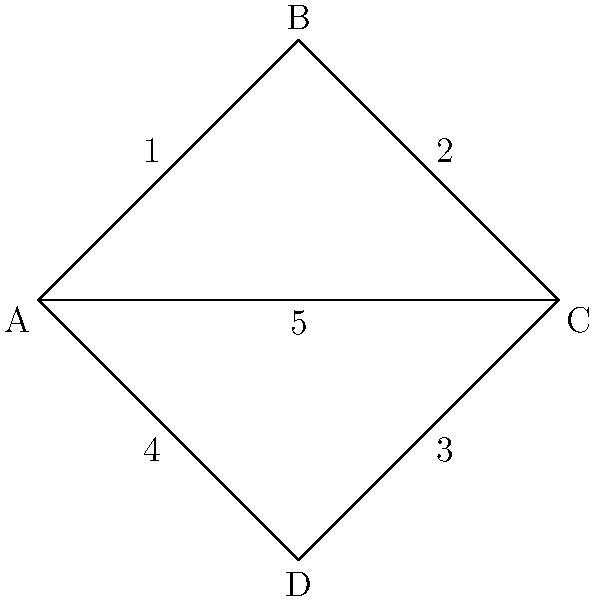Consider the simplified topology of Central Park's running paths shown in the diagram. Each vertex (A, B, C, D) represents a major intersection, and the edges represent running paths. If a jogger wants to complete a route that covers all paths without repeating any, what is the minimum number of times they must pass through any single intersection? To solve this problem, we need to follow these steps:

1. Identify the degree of each vertex:
   A: 3 edges (odd)
   B: 2 edges (even)
   C: 3 edges (odd)
   D: 2 edges (even)

2. Recall that in an Eulerian path (a path that covers all edges exactly once):
   - Either all vertices have even degree, or
   - Exactly two vertices have odd degree (start and end points)

3. In this case, we have two odd-degree vertices (A and C), which means:
   - The path must start at A and end at C (or vice versa)
   - We can cover all edges exactly once

4. However, the question asks about the minimum number of times we must pass through any single intersection. This occurs at the vertex with the highest degree.

5. Both A and C have the highest degree of 3.

6. To cover all edges connected to A or C, we must enter and exit these vertices at least once, and pass through one additional time.

Therefore, the minimum number of times we must pass through any single intersection (A or C) is 3.
Answer: 3 